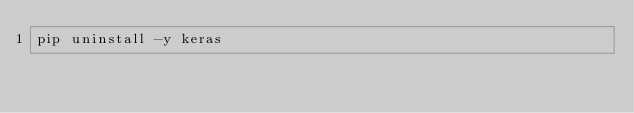<code> <loc_0><loc_0><loc_500><loc_500><_Bash_>pip uninstall -y keras
</code> 